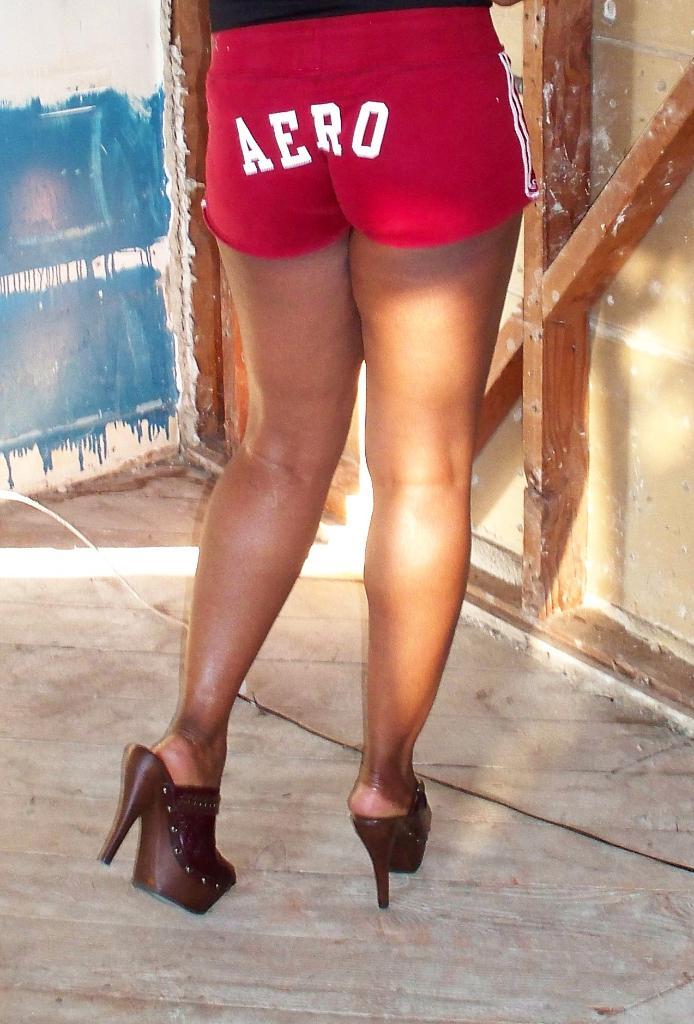What's on her butt?
Provide a succinct answer. Aero. What does it say on the back of this persons paints?
Give a very brief answer. Aero. 